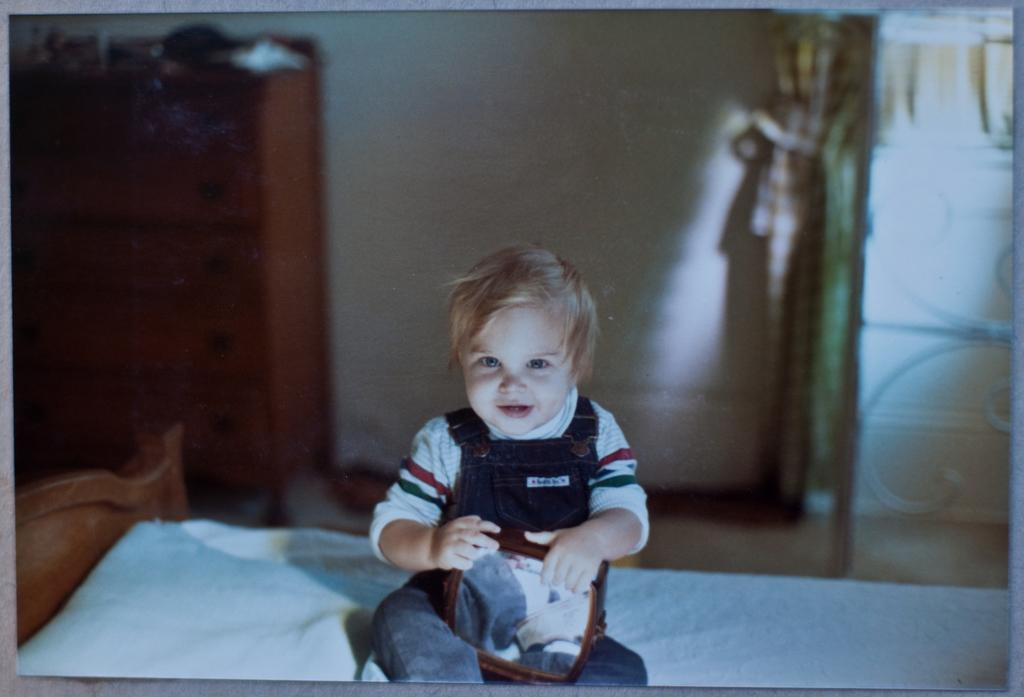What is the main subject of the image? There is a photo in the image. What is the kid doing in the image? The kid is holding an object in the image. Where is the kid sitting? The kid is sitting on a blanket in the image. What is the blanket placed on? The blanket is on a bed in the image. What can be seen in the background of the image? There is a wall and other objects in the background of the image. What type of trouble is the kid causing with the mitten in the image? There is no mitten present in the image, and the kid is not causing any trouble. 